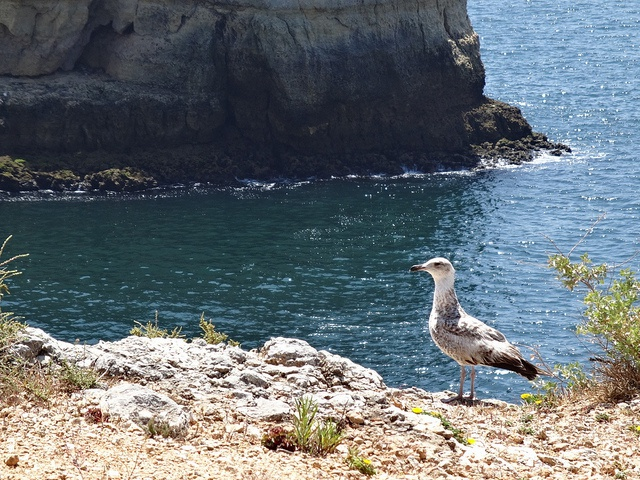Describe the objects in this image and their specific colors. I can see a bird in black, darkgray, gray, and white tones in this image. 